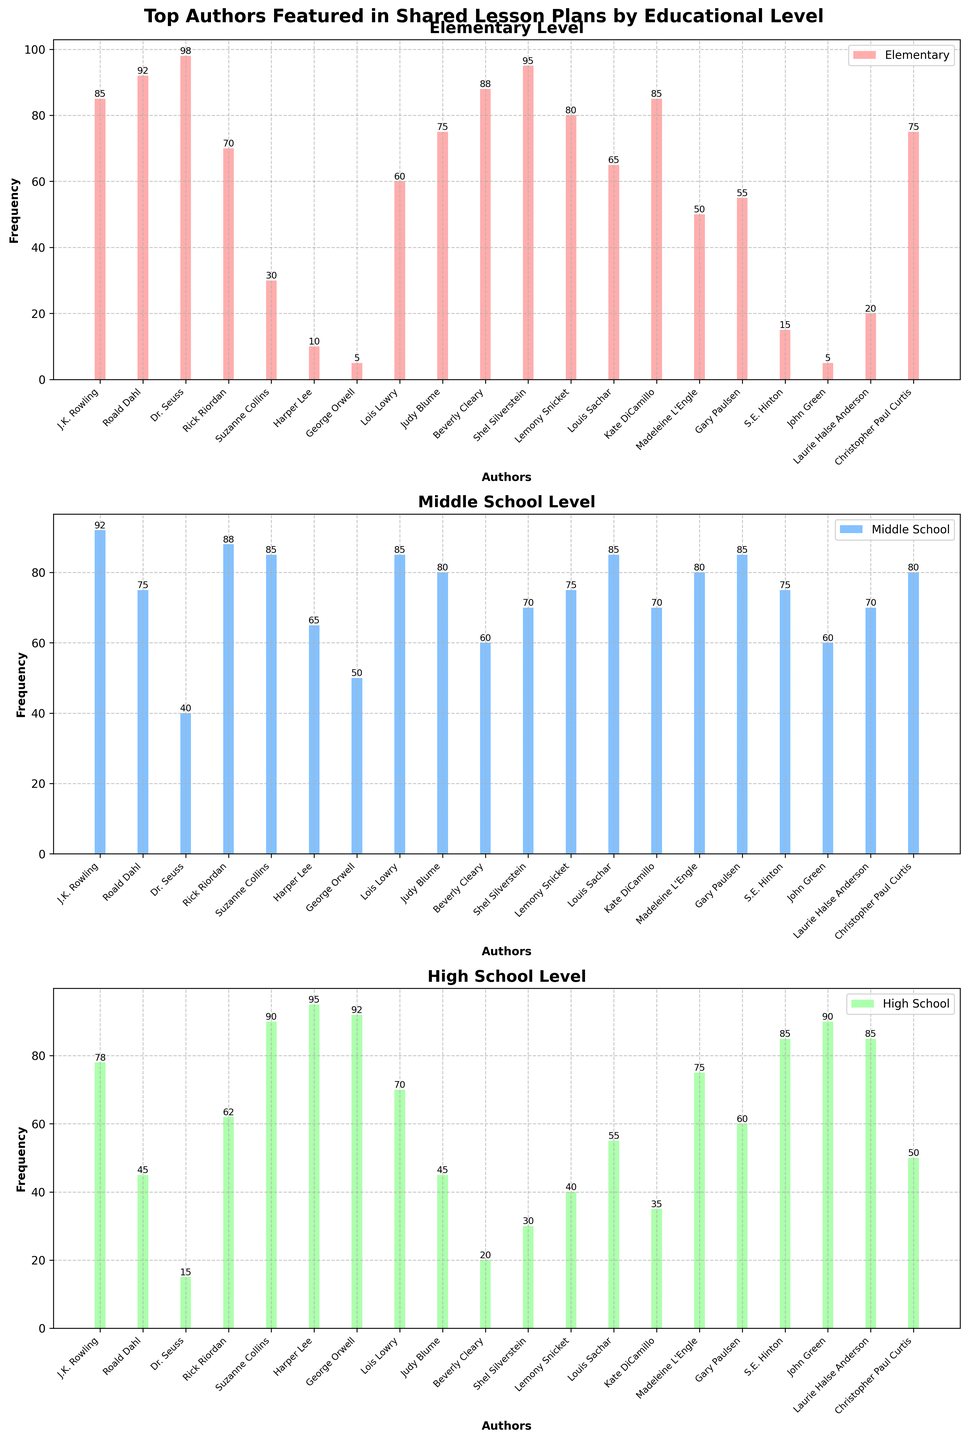How many more lesson plans feature Dr. Seuss at the Elementary level compared to the Middle School level? To find the answer, look at the heights of the bars corresponding to Dr. Seuss in the Elementary and Middle School subplots. Dr. Seuss has 98 plans at the Elementary level and 40 at the Middle School level. The difference is 98 - 40 = 58.
Answer: 58 Which author is equally popular at the Middle School and High School levels? Scan the height of the bars within both the Middle School and High School subplots to find any author with equal frequencies. Suzanne Collins has 85 plans at both levels.
Answer: Suzanne Collins For which author is there the largest frequency drop from Elementary to High School level? Compare the heights of the bars for each author at the Elementary and High School levels, and calculate the difference. Dr. Seuss has the largest drop: 98 (Elementary) - 15 (High School) = 83.
Answer: Dr. Seuss Which level showcases the highest number of lesson plans for Shel Silverstein? Check the heights of the bars for Shel Silverstein in all three subplots. The highest frequency is in Elementary with 95 lesson plans.
Answer: Elementary What is the total number of lesson plans featuring Harper Lee across all educational levels? Sum up the frequencies of Harper Lee from all three subplots: 10 (Elementary) + 65 (Middle School) + 95 (High School). The total is 10 + 65 + 95 = 170.
Answer: 170 Which author has the most lesson plans in the High School level? Look at the heights of the bars in the High School subplot and identify the tallest one. Harper Lee has the highest frequency with 95 lesson plans.
Answer: Harper Lee How much more frequently is J.K. Rowling featured in Middle School compared to High School? Refer to J.K. Rowling's bars in the Middle School and High School subplots. The difference is 92 (Middle School) - 78 (High School) = 14.
Answer: 14 Which author is featured in lesson plans for all three educational levels, and has the highest number at any specific level? Identify authors appearing in all three subplots, then determine which has the highest frequency in at least one level. Shel Silverstein is featured at all levels and has 95 lesson plans at Elementary, which is his highest number.
Answer: Shel Silverstein What is the average number of lesson plans for Rick Riordan across all educational levels? Add the frequencies of Rick Riordan from all three subplots and divide by 3: (70 + 88 + 62) / 3 = 220 / 3 ≈ 73.33.
Answer: 73.33 Which author featured in lesson plans is the least popular at the Elementary level? Identify the bar with the smallest height in the Elementary subplot. George Orwell, and John Green both have the smallest frequency with 5 lesson plans each.
Answer: George Orwell and John Green 